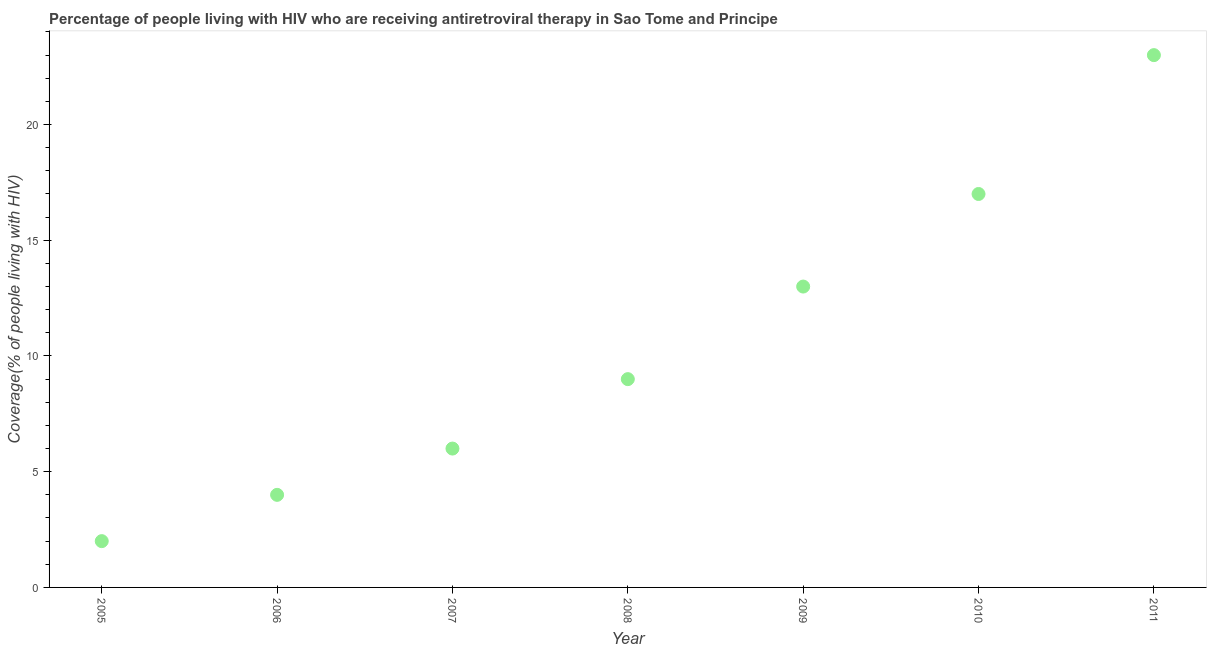What is the antiretroviral therapy coverage in 2011?
Offer a terse response. 23. Across all years, what is the maximum antiretroviral therapy coverage?
Make the answer very short. 23. Across all years, what is the minimum antiretroviral therapy coverage?
Keep it short and to the point. 2. In which year was the antiretroviral therapy coverage minimum?
Ensure brevity in your answer.  2005. What is the sum of the antiretroviral therapy coverage?
Provide a succinct answer. 74. What is the difference between the antiretroviral therapy coverage in 2009 and 2011?
Make the answer very short. -10. What is the average antiretroviral therapy coverage per year?
Provide a short and direct response. 10.57. What is the median antiretroviral therapy coverage?
Make the answer very short. 9. In how many years, is the antiretroviral therapy coverage greater than 14 %?
Ensure brevity in your answer.  2. Do a majority of the years between 2006 and 2011 (inclusive) have antiretroviral therapy coverage greater than 15 %?
Your answer should be compact. No. What is the ratio of the antiretroviral therapy coverage in 2005 to that in 2009?
Offer a terse response. 0.15. Is the antiretroviral therapy coverage in 2010 less than that in 2011?
Your response must be concise. Yes. Is the sum of the antiretroviral therapy coverage in 2006 and 2008 greater than the maximum antiretroviral therapy coverage across all years?
Provide a succinct answer. No. What is the difference between the highest and the lowest antiretroviral therapy coverage?
Offer a terse response. 21. In how many years, is the antiretroviral therapy coverage greater than the average antiretroviral therapy coverage taken over all years?
Offer a very short reply. 3. Does the antiretroviral therapy coverage monotonically increase over the years?
Your response must be concise. Yes. How many dotlines are there?
Your answer should be compact. 1. What is the difference between two consecutive major ticks on the Y-axis?
Offer a very short reply. 5. Does the graph contain any zero values?
Your answer should be compact. No. Does the graph contain grids?
Your answer should be very brief. No. What is the title of the graph?
Make the answer very short. Percentage of people living with HIV who are receiving antiretroviral therapy in Sao Tome and Principe. What is the label or title of the Y-axis?
Keep it short and to the point. Coverage(% of people living with HIV). What is the Coverage(% of people living with HIV) in 2005?
Your answer should be compact. 2. What is the difference between the Coverage(% of people living with HIV) in 2005 and 2007?
Give a very brief answer. -4. What is the difference between the Coverage(% of people living with HIV) in 2005 and 2009?
Your response must be concise. -11. What is the difference between the Coverage(% of people living with HIV) in 2006 and 2008?
Offer a very short reply. -5. What is the difference between the Coverage(% of people living with HIV) in 2007 and 2009?
Your response must be concise. -7. What is the difference between the Coverage(% of people living with HIV) in 2007 and 2010?
Provide a succinct answer. -11. What is the difference between the Coverage(% of people living with HIV) in 2008 and 2010?
Ensure brevity in your answer.  -8. What is the difference between the Coverage(% of people living with HIV) in 2009 and 2010?
Make the answer very short. -4. What is the ratio of the Coverage(% of people living with HIV) in 2005 to that in 2006?
Your answer should be very brief. 0.5. What is the ratio of the Coverage(% of people living with HIV) in 2005 to that in 2007?
Make the answer very short. 0.33. What is the ratio of the Coverage(% of people living with HIV) in 2005 to that in 2008?
Ensure brevity in your answer.  0.22. What is the ratio of the Coverage(% of people living with HIV) in 2005 to that in 2009?
Your answer should be compact. 0.15. What is the ratio of the Coverage(% of people living with HIV) in 2005 to that in 2010?
Offer a terse response. 0.12. What is the ratio of the Coverage(% of people living with HIV) in 2005 to that in 2011?
Ensure brevity in your answer.  0.09. What is the ratio of the Coverage(% of people living with HIV) in 2006 to that in 2007?
Your answer should be very brief. 0.67. What is the ratio of the Coverage(% of people living with HIV) in 2006 to that in 2008?
Make the answer very short. 0.44. What is the ratio of the Coverage(% of people living with HIV) in 2006 to that in 2009?
Make the answer very short. 0.31. What is the ratio of the Coverage(% of people living with HIV) in 2006 to that in 2010?
Offer a terse response. 0.23. What is the ratio of the Coverage(% of people living with HIV) in 2006 to that in 2011?
Offer a terse response. 0.17. What is the ratio of the Coverage(% of people living with HIV) in 2007 to that in 2008?
Provide a short and direct response. 0.67. What is the ratio of the Coverage(% of people living with HIV) in 2007 to that in 2009?
Ensure brevity in your answer.  0.46. What is the ratio of the Coverage(% of people living with HIV) in 2007 to that in 2010?
Your response must be concise. 0.35. What is the ratio of the Coverage(% of people living with HIV) in 2007 to that in 2011?
Offer a terse response. 0.26. What is the ratio of the Coverage(% of people living with HIV) in 2008 to that in 2009?
Provide a short and direct response. 0.69. What is the ratio of the Coverage(% of people living with HIV) in 2008 to that in 2010?
Your answer should be very brief. 0.53. What is the ratio of the Coverage(% of people living with HIV) in 2008 to that in 2011?
Offer a terse response. 0.39. What is the ratio of the Coverage(% of people living with HIV) in 2009 to that in 2010?
Make the answer very short. 0.77. What is the ratio of the Coverage(% of people living with HIV) in 2009 to that in 2011?
Give a very brief answer. 0.56. What is the ratio of the Coverage(% of people living with HIV) in 2010 to that in 2011?
Offer a terse response. 0.74. 